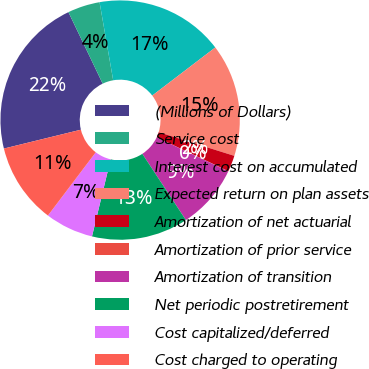<chart> <loc_0><loc_0><loc_500><loc_500><pie_chart><fcel>(Millions of Dollars)<fcel>Service cost<fcel>Interest cost on accumulated<fcel>Expected return on plan assets<fcel>Amortization of net actuarial<fcel>Amortization of prior service<fcel>Amortization of transition<fcel>Net periodic postretirement<fcel>Cost capitalized/deferred<fcel>Cost charged to operating<nl><fcel>21.72%<fcel>4.36%<fcel>17.38%<fcel>15.21%<fcel>2.19%<fcel>0.02%<fcel>8.7%<fcel>13.04%<fcel>6.53%<fcel>10.87%<nl></chart> 